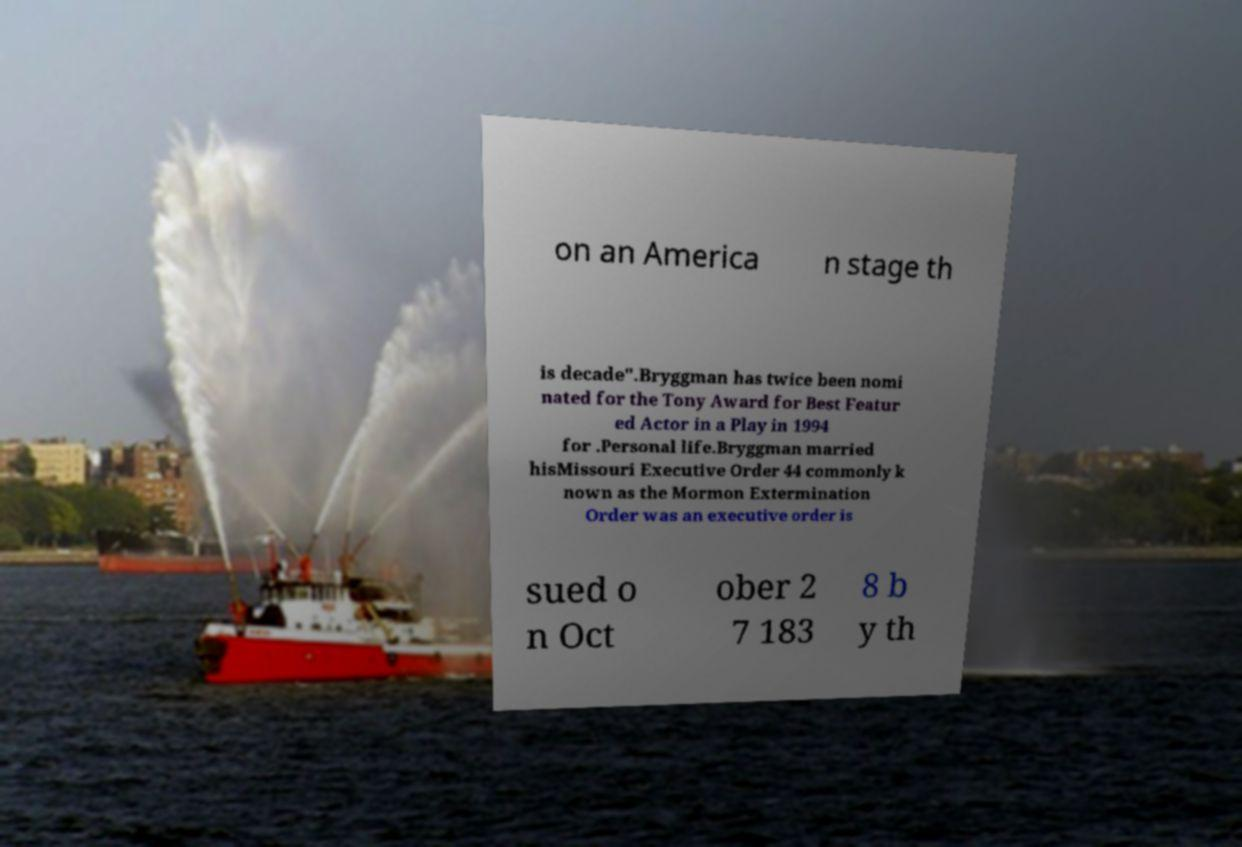Please read and relay the text visible in this image. What does it say? on an America n stage th is decade".Bryggman has twice been nomi nated for the Tony Award for Best Featur ed Actor in a Play in 1994 for .Personal life.Bryggman married hisMissouri Executive Order 44 commonly k nown as the Mormon Extermination Order was an executive order is sued o n Oct ober 2 7 183 8 b y th 